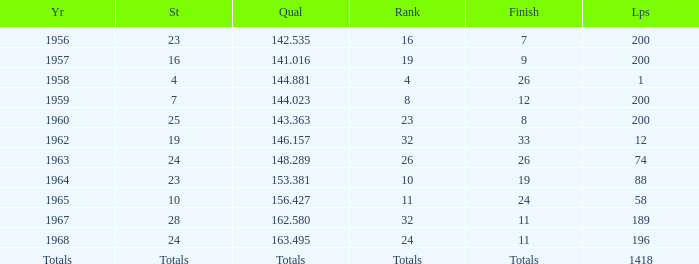Which qual has both 200 total laps and took place in 1957? 141.016. 